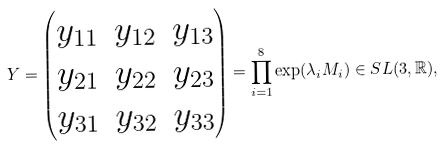Convert formula to latex. <formula><loc_0><loc_0><loc_500><loc_500>Y = \begin{pmatrix} y _ { 1 1 } & y _ { 1 2 } & y _ { 1 3 } \\ y _ { 2 1 } & y _ { 2 2 } & y _ { 2 3 } \\ y _ { 3 1 } & y _ { 3 2 } & y _ { 3 3 } \end{pmatrix} = \prod _ { i = 1 } ^ { 8 } \exp ( \lambda _ { i } M _ { i } ) \in S L ( 3 , \mathbb { R } ) ,</formula> 